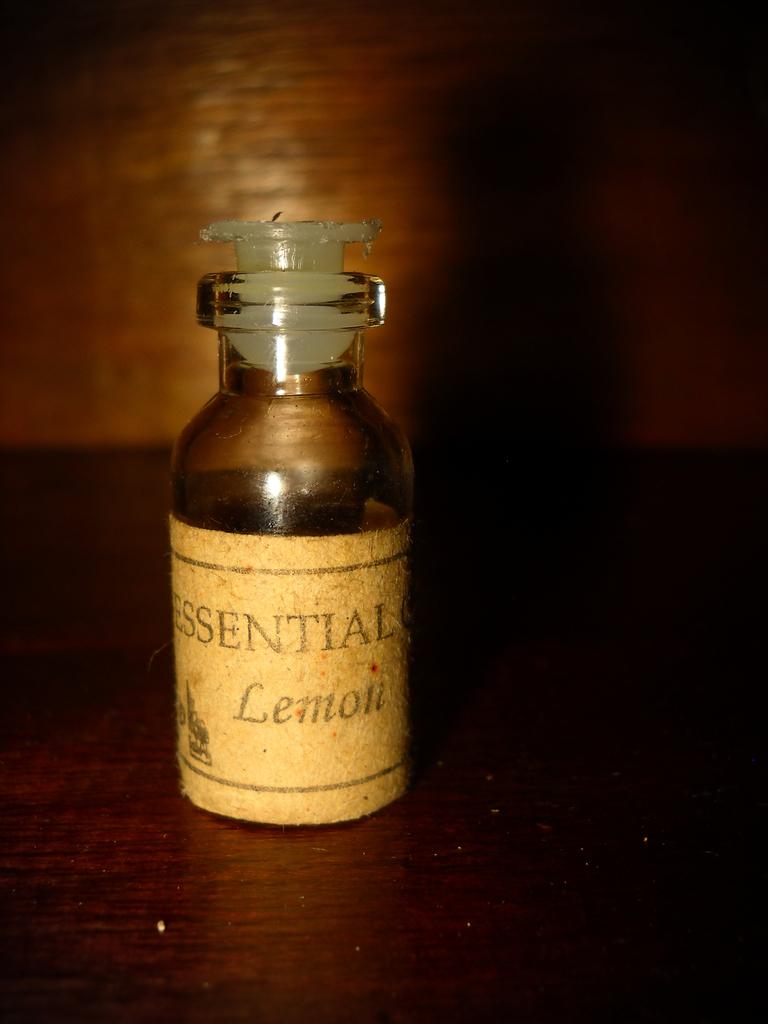What type of lemon does it say it is?
Provide a succinct answer. Essential. 